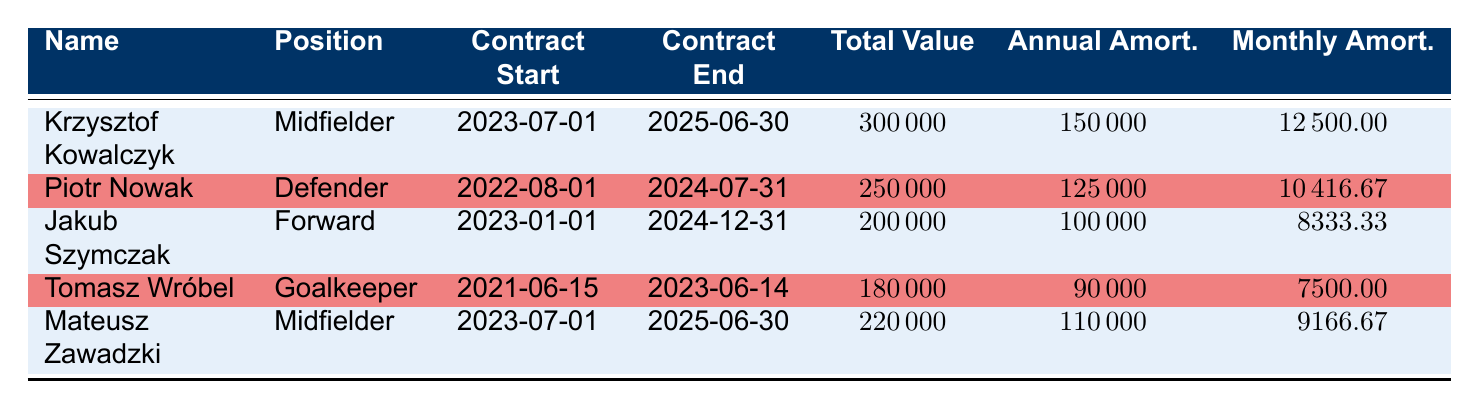What is the total contract value for Krzysztof Kowalczyk? The total contract value for Krzysztof Kowalczyk is listed directly in the table under the "Total Value" column. It shows 300000.
Answer: 300000 What position does Piotr Nowak play? The position of Piotr Nowak is specified in the table under the "Position" column. He is recorded as a Defender.
Answer: Defender How long is the contract period for Jakub Szymczak? To find the contract period, we need to calculate the difference between the contract start date (2023-01-01) and the contract end date (2024-12-31). This spans from January 2023 to December 2024, which totals to 2 years.
Answer: 2 years What is the average monthly amortization for all players? The monthly amortizations are 12500, 10416.67, 8333.33, 7500, and 9166.67. Adding these values gives 50000, and dividing by 5 (the number of players) results in an average of 10000.
Answer: 10000 Is Mateusz Zawadzki's total contract value higher than that of Tomasz Wróbel? The total contract value for Mateusz Zawadzki is 220000, while for Tomasz Wróbel it is 180000. Since 220000 is greater than 180000, the statement is true.
Answer: Yes What is the difference in annual amortization between Krzysztof Kowalczyk and Jakub Szymczak? The annual amortization for Krzysztof Kowalczyk is 150000 and for Jakub Szymczak it is 100000. The difference is calculated as 150000 - 100000, which equals 50000.
Answer: 50000 How many players have contracts ending in 2024? By inspecting the "Contract End" column, we find that Piotr Nowak and Jakub Szymczak have contracts that end in 2024. Thus, there are 2 players with contracts ending in 2024.
Answer: 2 Which player has the highest annual amortization? By examining the "Annual Amort." column, Krzysztof Kowalczyk has the highest annual amortization of 150000, compared to the other players.
Answer: Krzysztof Kowalczyk What are the names of players who play as Midfielders? Looking at the "Position" column, Krzysztof Kowalczyk and Mateusz Zawadzki are qualified as Midfielders. Thus, their names are both mid-fielders.
Answer: Krzysztof Kowalczyk, Mateusz Zawadzki 